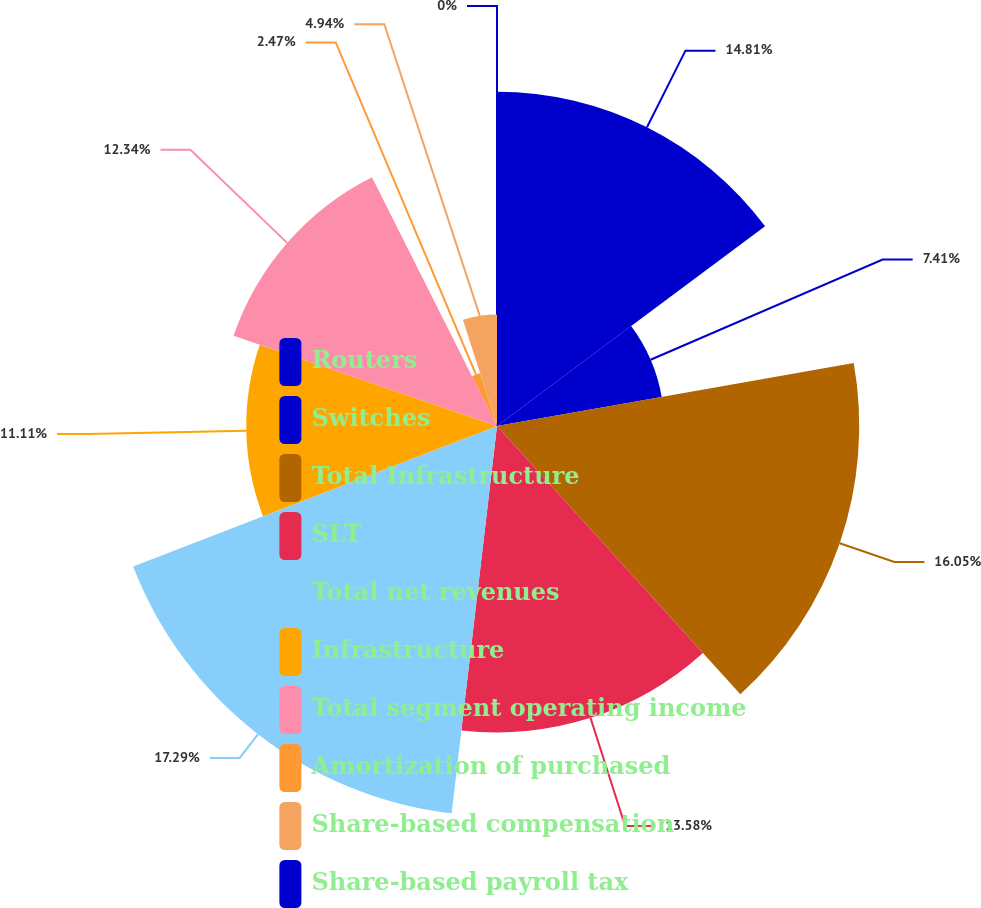Convert chart to OTSL. <chart><loc_0><loc_0><loc_500><loc_500><pie_chart><fcel>Routers<fcel>Switches<fcel>Total Infrastructure<fcel>SLT<fcel>Total net revenues<fcel>Infrastructure<fcel>Total segment operating income<fcel>Amortization of purchased<fcel>Share-based compensation<fcel>Share-based payroll tax<nl><fcel>14.81%<fcel>7.41%<fcel>16.05%<fcel>13.58%<fcel>17.28%<fcel>11.11%<fcel>12.34%<fcel>2.47%<fcel>4.94%<fcel>0.0%<nl></chart> 